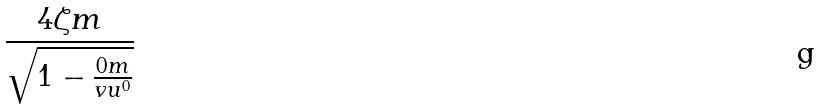<formula> <loc_0><loc_0><loc_500><loc_500>\frac { 4 \zeta m } { \sqrt { 1 - \frac { 0 m } { v u ^ { 0 } } } }</formula> 